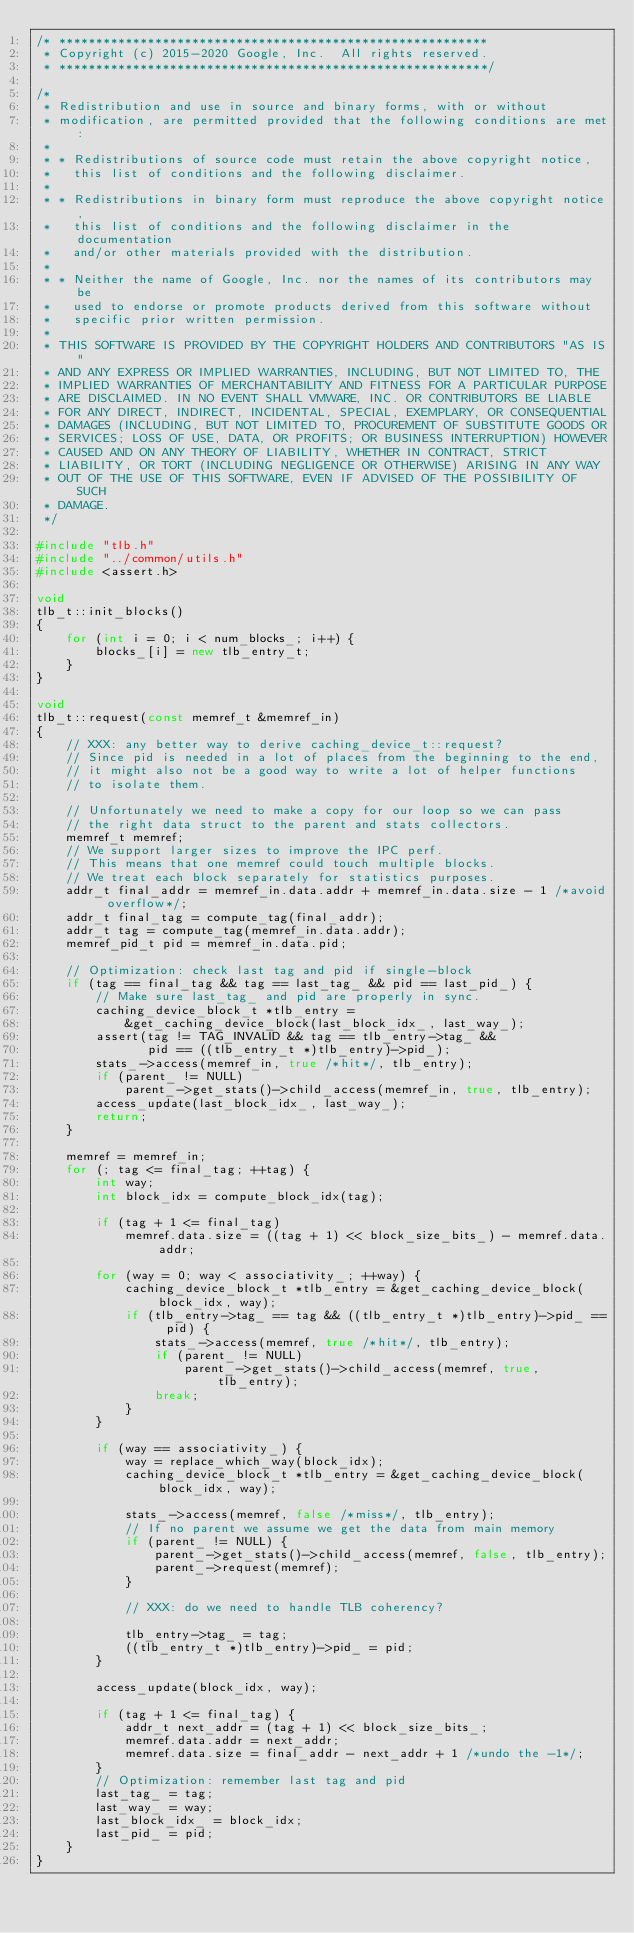Convert code to text. <code><loc_0><loc_0><loc_500><loc_500><_C++_>/* **********************************************************
 * Copyright (c) 2015-2020 Google, Inc.  All rights reserved.
 * **********************************************************/

/*
 * Redistribution and use in source and binary forms, with or without
 * modification, are permitted provided that the following conditions are met:
 *
 * * Redistributions of source code must retain the above copyright notice,
 *   this list of conditions and the following disclaimer.
 *
 * * Redistributions in binary form must reproduce the above copyright notice,
 *   this list of conditions and the following disclaimer in the documentation
 *   and/or other materials provided with the distribution.
 *
 * * Neither the name of Google, Inc. nor the names of its contributors may be
 *   used to endorse or promote products derived from this software without
 *   specific prior written permission.
 *
 * THIS SOFTWARE IS PROVIDED BY THE COPYRIGHT HOLDERS AND CONTRIBUTORS "AS IS"
 * AND ANY EXPRESS OR IMPLIED WARRANTIES, INCLUDING, BUT NOT LIMITED TO, THE
 * IMPLIED WARRANTIES OF MERCHANTABILITY AND FITNESS FOR A PARTICULAR PURPOSE
 * ARE DISCLAIMED. IN NO EVENT SHALL VMWARE, INC. OR CONTRIBUTORS BE LIABLE
 * FOR ANY DIRECT, INDIRECT, INCIDENTAL, SPECIAL, EXEMPLARY, OR CONSEQUENTIAL
 * DAMAGES (INCLUDING, BUT NOT LIMITED TO, PROCUREMENT OF SUBSTITUTE GOODS OR
 * SERVICES; LOSS OF USE, DATA, OR PROFITS; OR BUSINESS INTERRUPTION) HOWEVER
 * CAUSED AND ON ANY THEORY OF LIABILITY, WHETHER IN CONTRACT, STRICT
 * LIABILITY, OR TORT (INCLUDING NEGLIGENCE OR OTHERWISE) ARISING IN ANY WAY
 * OUT OF THE USE OF THIS SOFTWARE, EVEN IF ADVISED OF THE POSSIBILITY OF SUCH
 * DAMAGE.
 */

#include "tlb.h"
#include "../common/utils.h"
#include <assert.h>

void
tlb_t::init_blocks()
{
    for (int i = 0; i < num_blocks_; i++) {
        blocks_[i] = new tlb_entry_t;
    }
}

void
tlb_t::request(const memref_t &memref_in)
{
    // XXX: any better way to derive caching_device_t::request?
    // Since pid is needed in a lot of places from the beginning to the end,
    // it might also not be a good way to write a lot of helper functions
    // to isolate them.

    // Unfortunately we need to make a copy for our loop so we can pass
    // the right data struct to the parent and stats collectors.
    memref_t memref;
    // We support larger sizes to improve the IPC perf.
    // This means that one memref could touch multiple blocks.
    // We treat each block separately for statistics purposes.
    addr_t final_addr = memref_in.data.addr + memref_in.data.size - 1 /*avoid overflow*/;
    addr_t final_tag = compute_tag(final_addr);
    addr_t tag = compute_tag(memref_in.data.addr);
    memref_pid_t pid = memref_in.data.pid;

    // Optimization: check last tag and pid if single-block
    if (tag == final_tag && tag == last_tag_ && pid == last_pid_) {
        // Make sure last_tag_ and pid are properly in sync.
        caching_device_block_t *tlb_entry =
            &get_caching_device_block(last_block_idx_, last_way_);
        assert(tag != TAG_INVALID && tag == tlb_entry->tag_ &&
               pid == ((tlb_entry_t *)tlb_entry)->pid_);
        stats_->access(memref_in, true /*hit*/, tlb_entry);
        if (parent_ != NULL)
            parent_->get_stats()->child_access(memref_in, true, tlb_entry);
        access_update(last_block_idx_, last_way_);
        return;
    }

    memref = memref_in;
    for (; tag <= final_tag; ++tag) {
        int way;
        int block_idx = compute_block_idx(tag);

        if (tag + 1 <= final_tag)
            memref.data.size = ((tag + 1) << block_size_bits_) - memref.data.addr;

        for (way = 0; way < associativity_; ++way) {
            caching_device_block_t *tlb_entry = &get_caching_device_block(block_idx, way);
            if (tlb_entry->tag_ == tag && ((tlb_entry_t *)tlb_entry)->pid_ == pid) {
                stats_->access(memref, true /*hit*/, tlb_entry);
                if (parent_ != NULL)
                    parent_->get_stats()->child_access(memref, true, tlb_entry);
                break;
            }
        }

        if (way == associativity_) {
            way = replace_which_way(block_idx);
            caching_device_block_t *tlb_entry = &get_caching_device_block(block_idx, way);

            stats_->access(memref, false /*miss*/, tlb_entry);
            // If no parent we assume we get the data from main memory
            if (parent_ != NULL) {
                parent_->get_stats()->child_access(memref, false, tlb_entry);
                parent_->request(memref);
            }

            // XXX: do we need to handle TLB coherency?

            tlb_entry->tag_ = tag;
            ((tlb_entry_t *)tlb_entry)->pid_ = pid;
        }

        access_update(block_idx, way);

        if (tag + 1 <= final_tag) {
            addr_t next_addr = (tag + 1) << block_size_bits_;
            memref.data.addr = next_addr;
            memref.data.size = final_addr - next_addr + 1 /*undo the -1*/;
        }
        // Optimization: remember last tag and pid
        last_tag_ = tag;
        last_way_ = way;
        last_block_idx_ = block_idx;
        last_pid_ = pid;
    }
}
</code> 